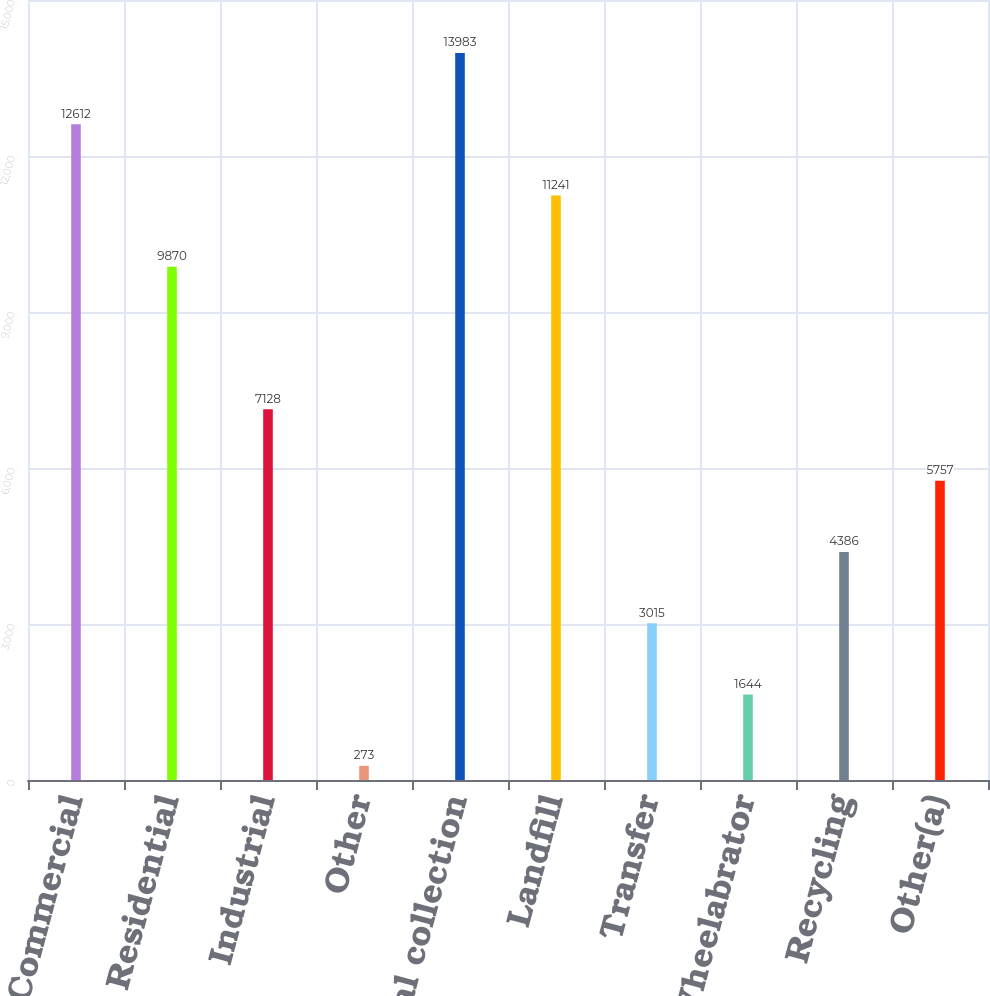<chart> <loc_0><loc_0><loc_500><loc_500><bar_chart><fcel>Commercial<fcel>Residential<fcel>Industrial<fcel>Other<fcel>Total collection<fcel>Landfill<fcel>Transfer<fcel>Wheelabrator<fcel>Recycling<fcel>Other(a)<nl><fcel>12612<fcel>9870<fcel>7128<fcel>273<fcel>13983<fcel>11241<fcel>3015<fcel>1644<fcel>4386<fcel>5757<nl></chart> 